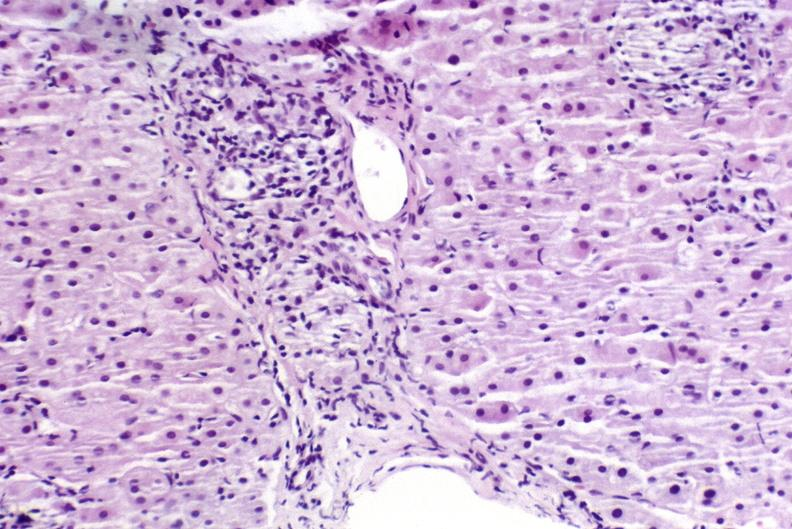s liver present?
Answer the question using a single word or phrase. Yes 